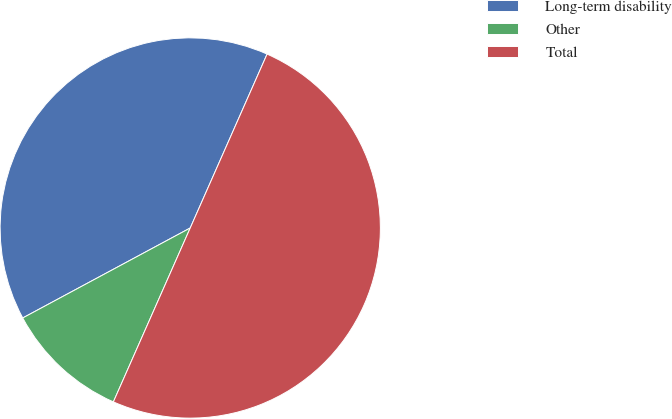Convert chart. <chart><loc_0><loc_0><loc_500><loc_500><pie_chart><fcel>Long-term disability<fcel>Other<fcel>Total<nl><fcel>39.47%<fcel>10.53%<fcel>50.0%<nl></chart> 